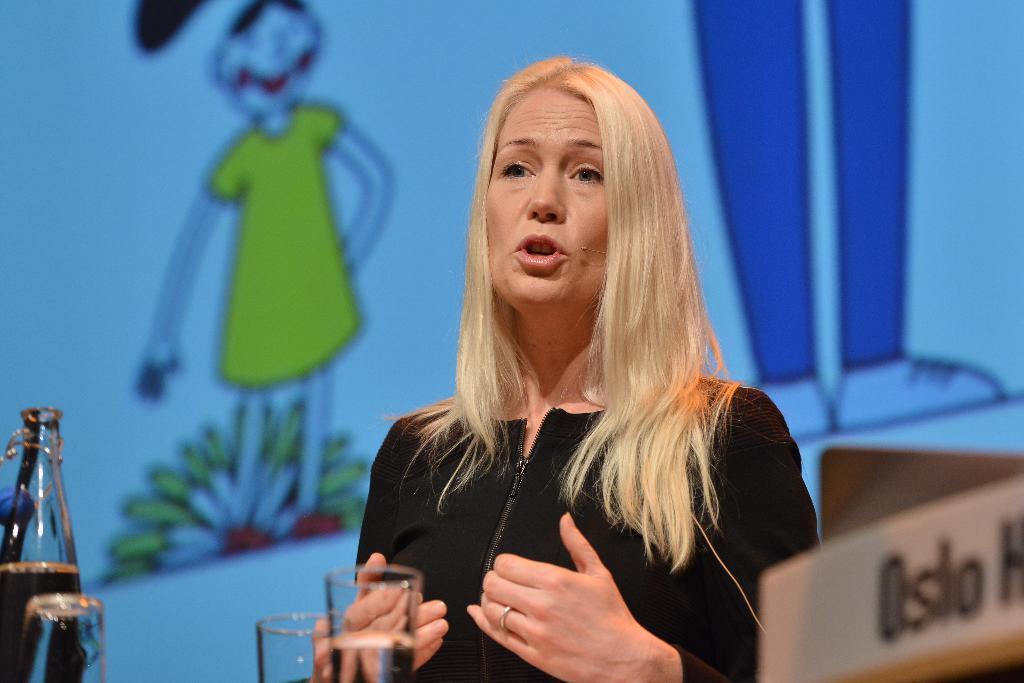In one or two sentences, can you explain what this image depicts? In this picture there is a woman who is talking. There is a glass, bottle and a nameplate on the table. There is a sketch at the background. 